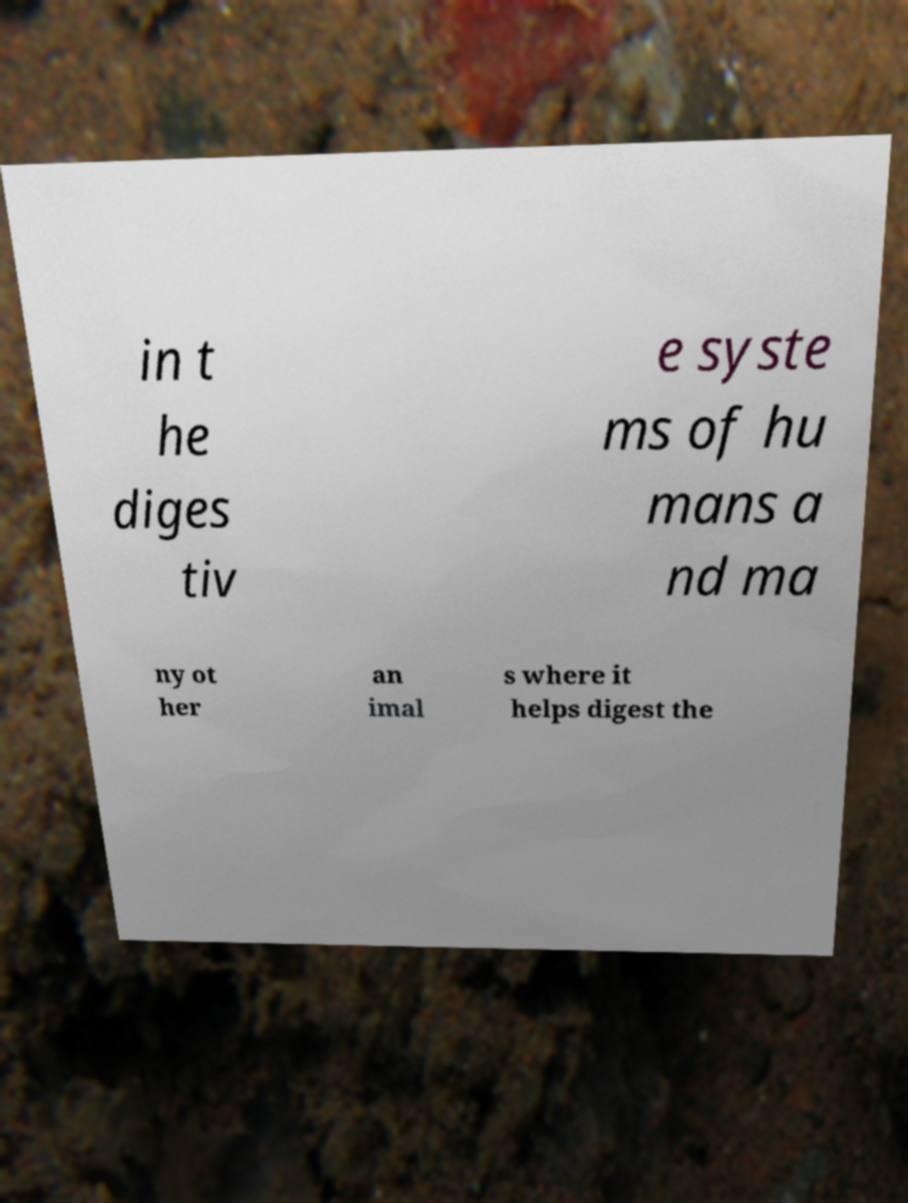Please identify and transcribe the text found in this image. in t he diges tiv e syste ms of hu mans a nd ma ny ot her an imal s where it helps digest the 